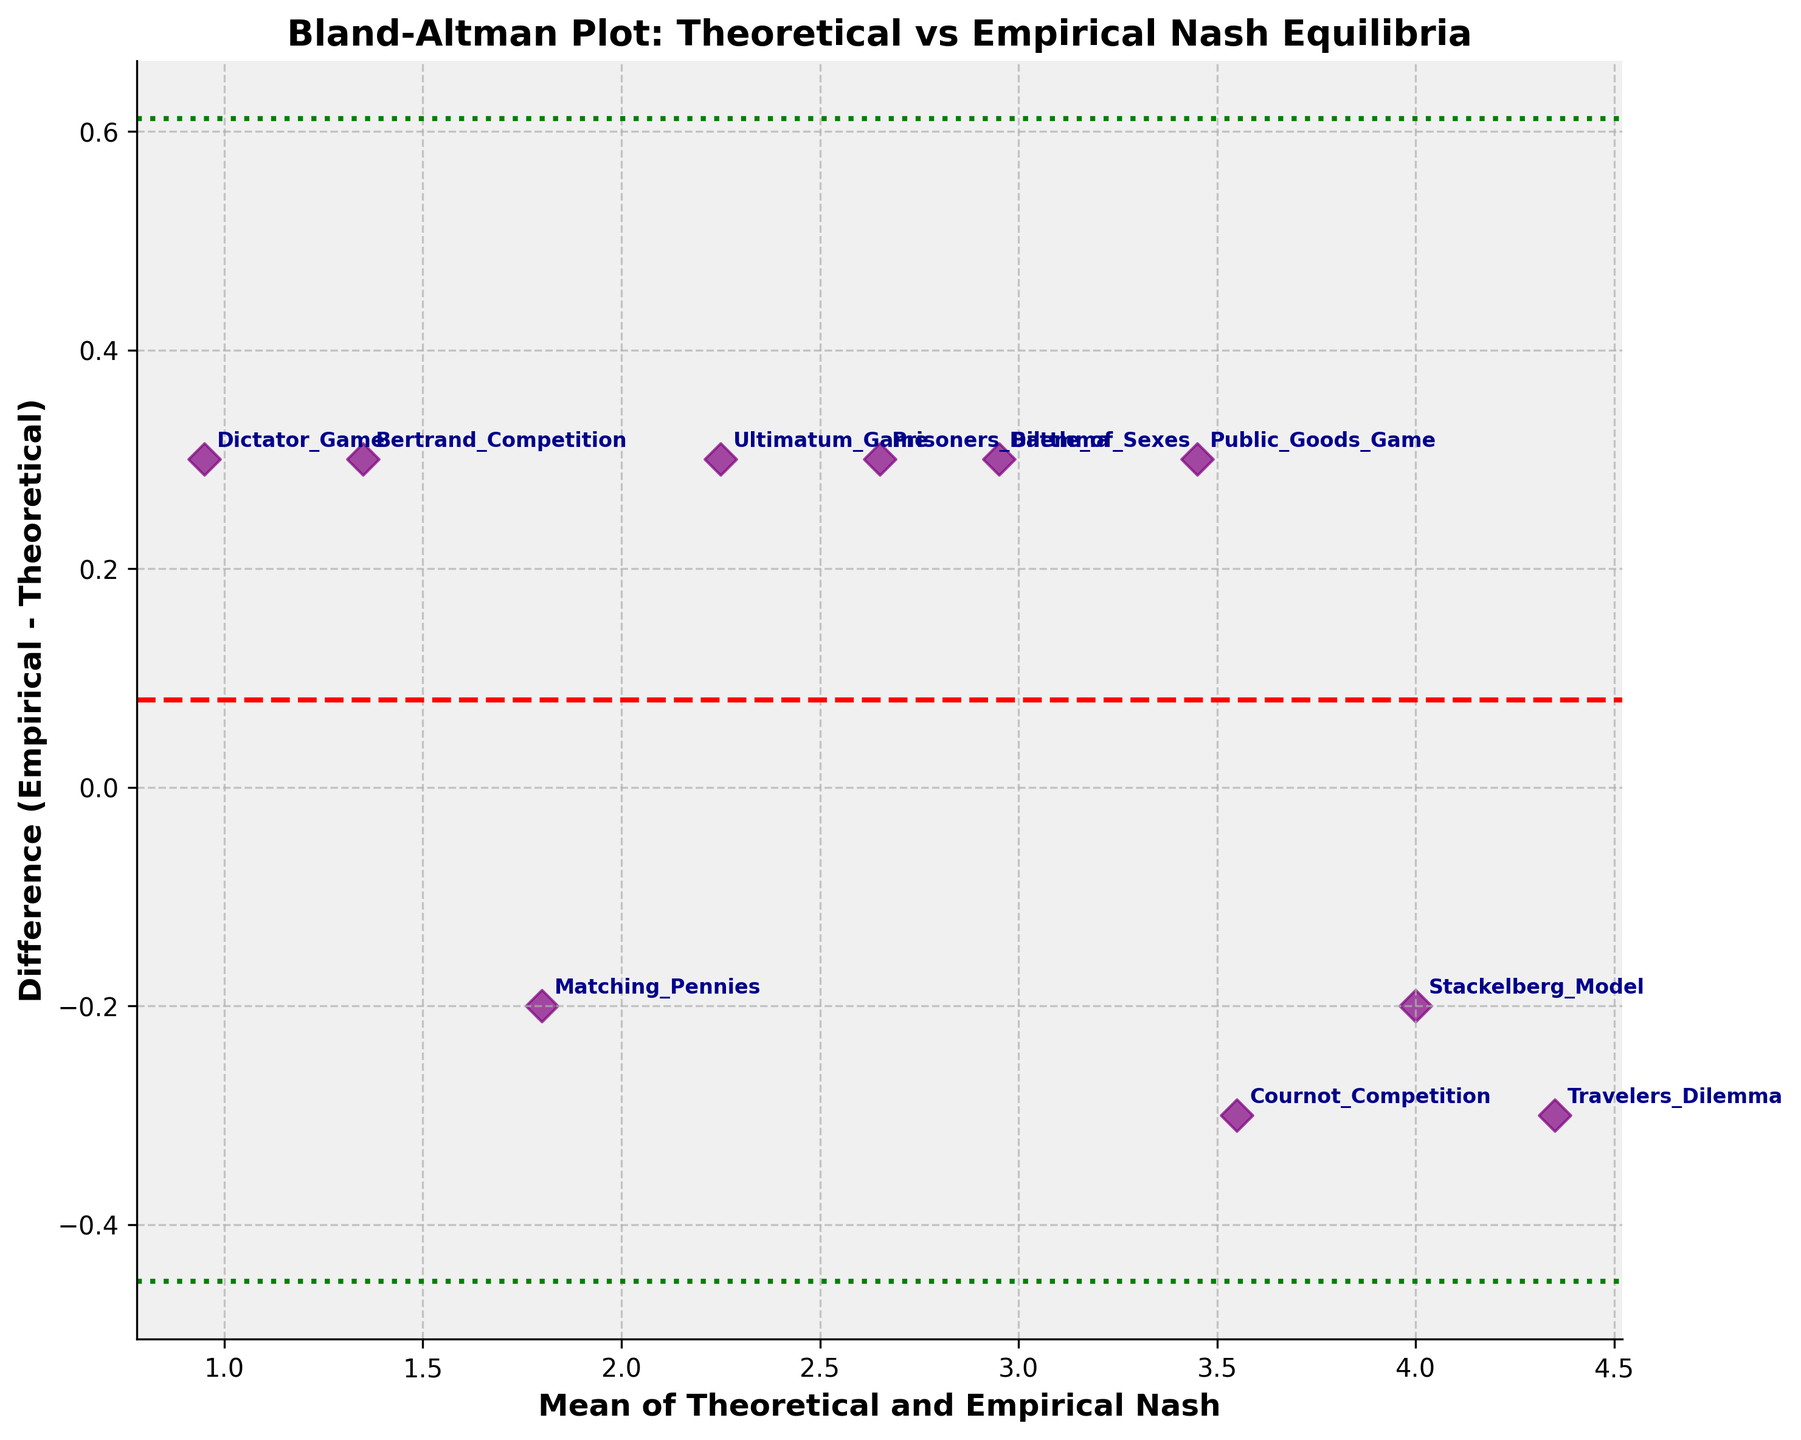How many data points are shown in the plot? We just need to count the number of discrete markers that represent each method. There are 10 markers, one for each method listed in the data.
Answer: 10 What is the title of the plot? The title is given at the top of the plot and summarizes the main idea. It reads "Bland-Altman Plot: Theoretical vs Empirical Nash Equilibria".
Answer: Bland-Altman Plot: Theoretical vs Empirical Nash Equilibria Which method has the highest mean value in the plot? We identify the data point with the highest x-coordinate, which represents the mean value of Theoretical and Empirical Nash. The data point with the highest mean is "Traveler's Dilemma" at 4.35.
Answer: Traveler's Dilemma Which methods have a positive difference between Empirical and Theoretical Nash equilibria? Positive differences are above the horizontal axis (y > 0). The methods above the axis are "Prisoners_Dilemma", "Bertrand_Competition", "Battle_of_Sexes", "Public_Goods_Game", "Ultimatum_Game", and "Dictator_Game".
Answer: Prisoners_Dilemma, Bertrand_Competition, Battle_of_Sexes, Public_Goods_Game, Ultimatum_Game, Dictator_Game What is the mean difference of all data points? The mean difference is represented by the red dashed line. We calculate it as the average of the differences: (0.3 - 0.3 + 0.3 - 0.2 + 0.3 - 0.2 + 0.3 + 0.3 + 0.3 - 0.3) / 10 = 0.10.
Answer: 0.10 Are there any methods with the same difference value? If so, what are they? Identical difference values will be on the same horizontal line with the same y-coordinate. The value 0.3 appears multiple times, corresponding to several methods. The methods with a difference of 0.3 are: "Prisoners_Dilemma", "Bertrand_Competition", "Battle_of_Sexes", "Public_Goods_Game", "Ultimatum_Game", "Dictator_Game".
Answer: Prisoners_Dilemma, Bertrand_Competition, Battle_of_Sexes, Public_Goods_Game, Ultimatum_Game, Dictator_Game Which method has the greatest difference between Empirical and Theoretical Nash? We identify the data point farthest from the horizontal axis, specifically looking at the absolute value. Both "Prisoners_Dilemma" and "Dictator_Game" share the highest difference at 0.3 in absolute terms.
Answer: Prisoners_Dilemma, Dictator_Game What is the difference between the Empirical and Theoretical Nash equilibria for "Stackelberg_Model"? We find the corresponding point for "Stackelberg_Model" labeled on the plot and see its y-coordinate value. The difference is -0.2.
Answer: -0.2 What do the green dotted lines represent in the plot? Typically, in Bland-Altman plots, green dotted lines represent the limits of agreement, calculated as the mean difference plus/minus 1.96 times the standard deviation of the differences.
Answer: Limits of agreement Are most of the methods clustered around a positive or negative difference? By visually inspecting, we see that many points are above the horizontal axis representing positive differences.
Answer: Positive 